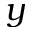<formula> <loc_0><loc_0><loc_500><loc_500>y</formula> 